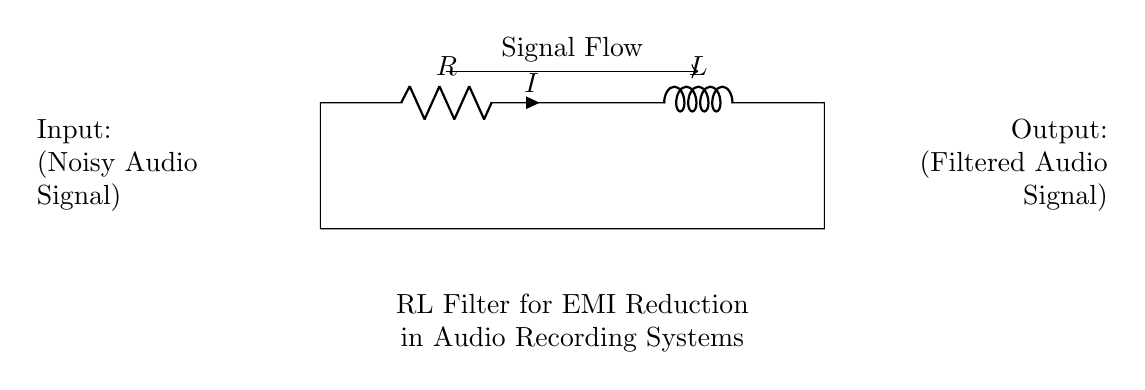What are the components in this circuit? The circuit contains a resistor and an inductor, as indicated by the labels. These are the two components that are essential for the RL filter circuit designed to reduce electromagnetic interference.
Answer: Resistor, Inductor What is the purpose of this circuit? The purpose of this circuit is to filter out electromagnetic interference from audio signals, thereby enhancing the quality of oral history recordings. This is inferred from the label that states "RL Filter for EMI Reduction in Audio Recording Systems".
Answer: EMI Reduction What is the current flow direction? The current flow direction is from the input on the left to the output on the right, as indicated by the arrow in the signal flow label. This shows the expected direction of the audio signal passing through the circuit.
Answer: Left to Right Which component is responsible for filtering in this circuit? The inductor is the component responsible for filtering, as it is primarily used for its ability to oppose changes in current and smooth out fluctuations in the signal, reducing electromagnetic interference.
Answer: Inductor What type of filter does this RL circuit represent? This RL circuit represents a low-pass filter, as it allows low-frequency signals to pass while attenuating high-frequency noise, thus enhancing the quality of audio recordings.
Answer: Low-pass filter What is the input to this circuit? The input to the circuit is a noisy audio signal, as indicated in the circuit diagram where it states “Noisy Audio Signal” at the input side. This provides context for what the circuit will process.
Answer: Noisy Audio Signal What is the output of this circuit? The output of this circuit is a filtered audio signal, which suggests that the circuit is designed to provide a cleaner version of the input signal after processing through the resistor and inductor.
Answer: Filtered Audio Signal 